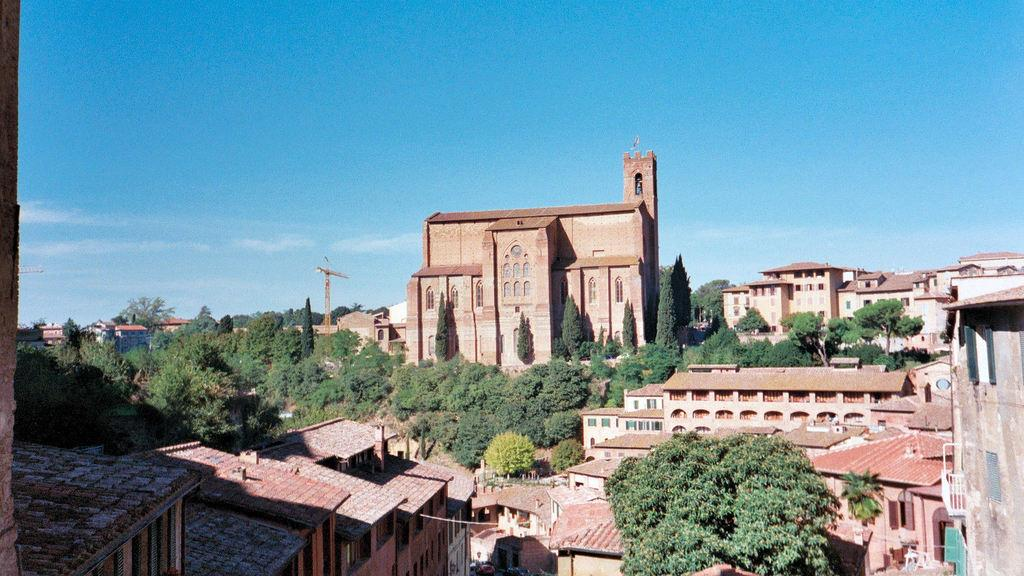What is the predominant color of the buildings in the image? The buildings in the image are predominantly brown-colored. What can be seen between the buildings? There are trees between the buildings. What is located in the background of the image? There is a pole and clouds visible in the background. What is the color of the sky in the background? The sky is blue in the background. What rhythm does the scene in the image follow? The image does not have a rhythm, as it is a still photograph and not a musical composition. 